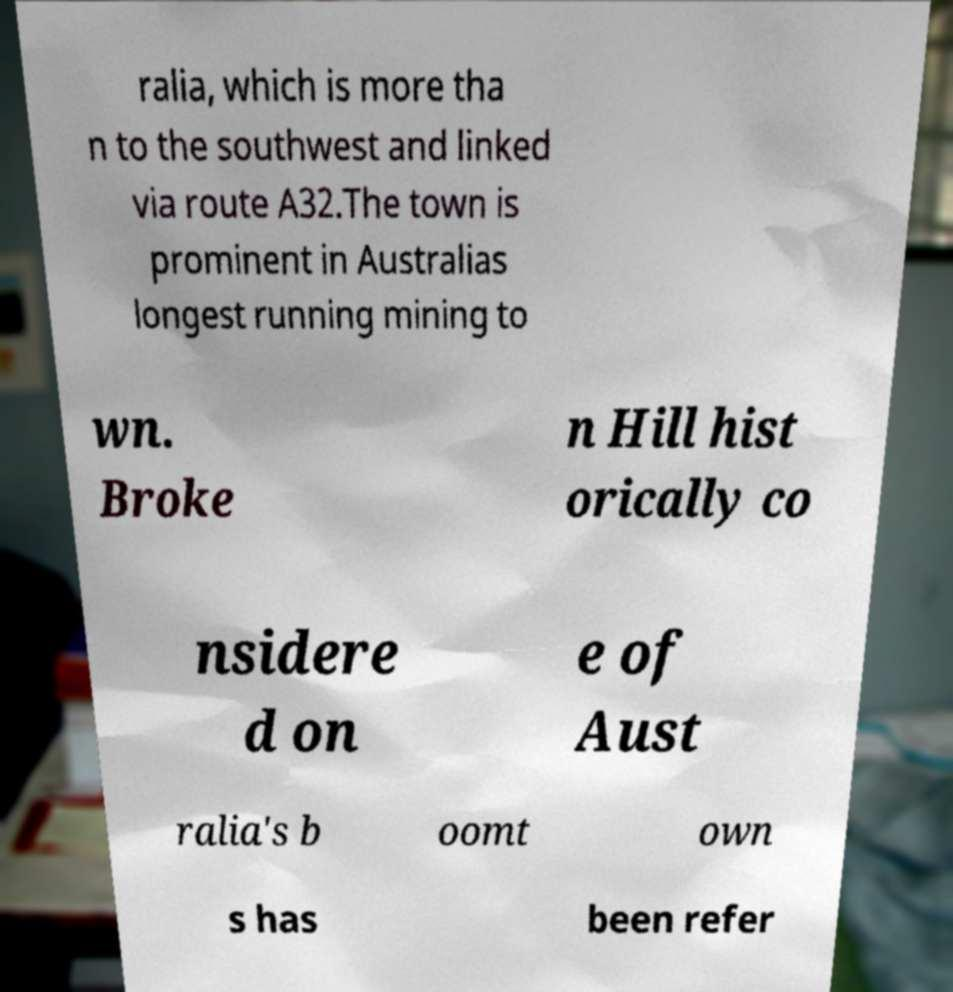What messages or text are displayed in this image? I need them in a readable, typed format. ralia, which is more tha n to the southwest and linked via route A32.The town is prominent in Australias longest running mining to wn. Broke n Hill hist orically co nsidere d on e of Aust ralia's b oomt own s has been refer 